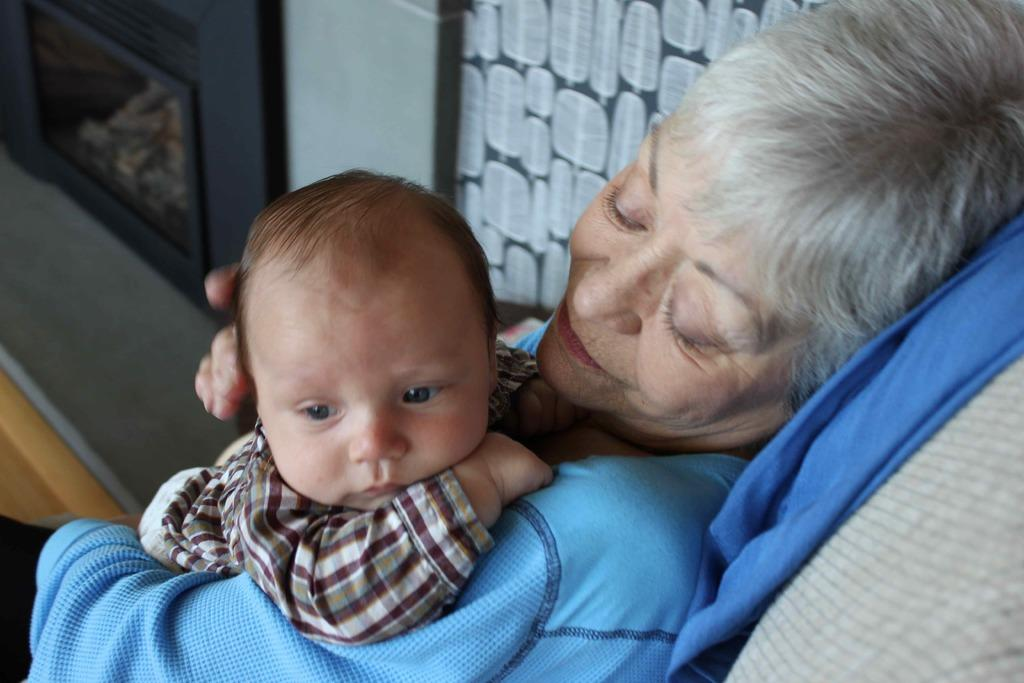Who is the main subject in the image? There is a woman in the image. What is the woman wearing? The woman is wearing a blue dress. What is the woman doing in the image? The woman is holding a baby. What type of rhythm can be heard in the background of the image? There is no audible rhythm present in the image, as it is a still photograph. 